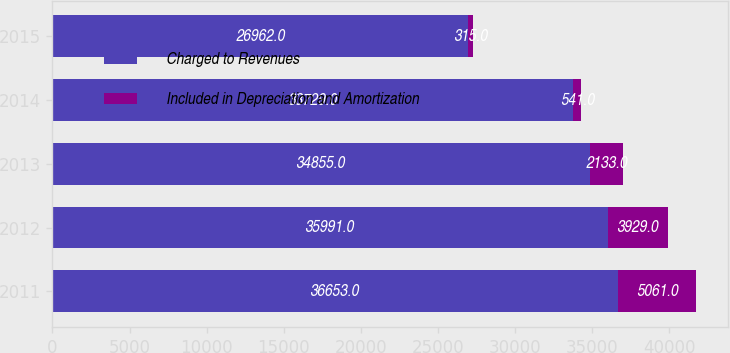<chart> <loc_0><loc_0><loc_500><loc_500><stacked_bar_chart><ecel><fcel>2011<fcel>2012<fcel>2013<fcel>2014<fcel>2015<nl><fcel>Charged to Revenues<fcel>36653<fcel>35991<fcel>34855<fcel>33729<fcel>26962<nl><fcel>Included in Depreciation and Amortization<fcel>5061<fcel>3929<fcel>2133<fcel>541<fcel>315<nl></chart> 